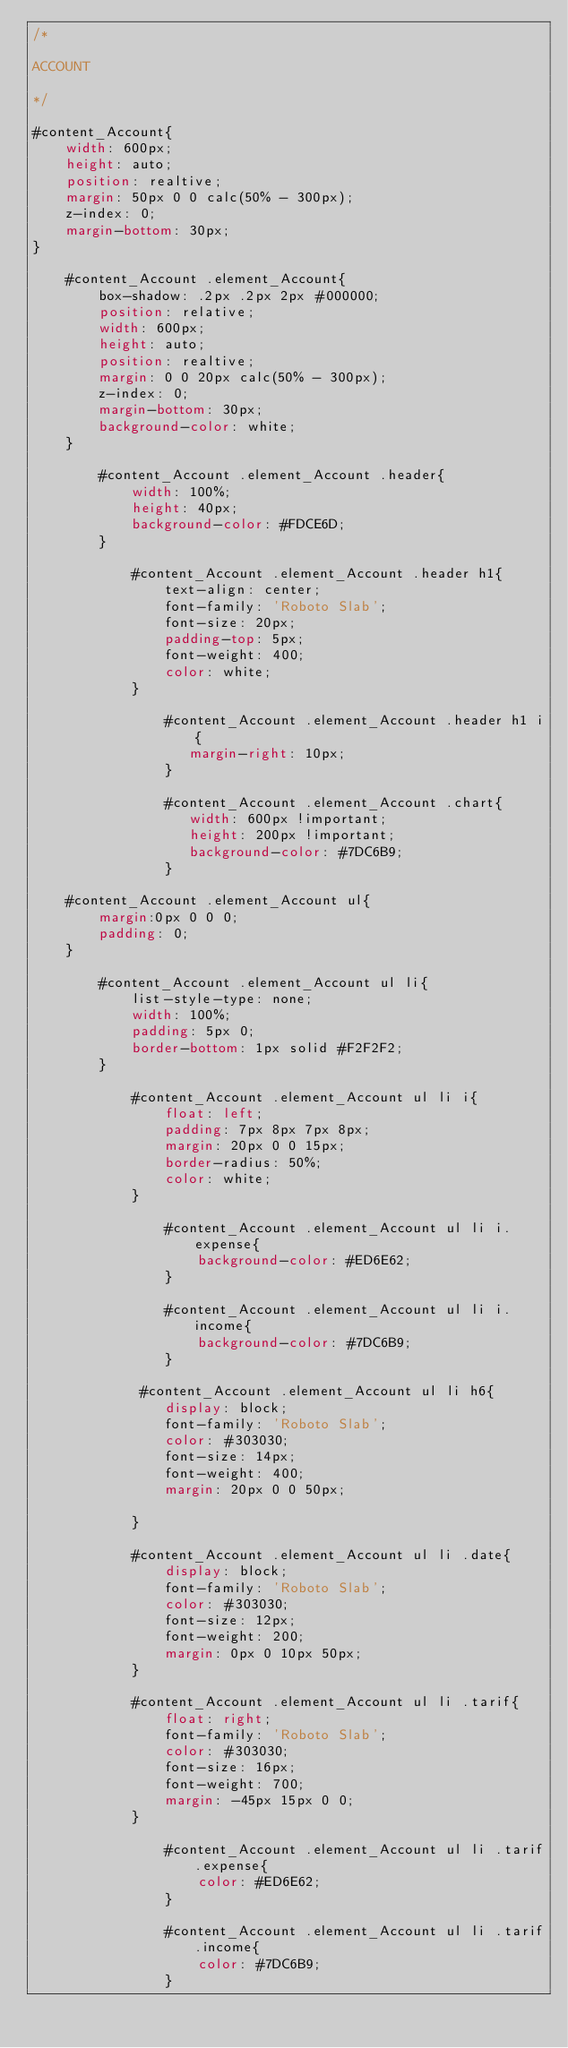<code> <loc_0><loc_0><loc_500><loc_500><_CSS_>/*

ACCOUNT

*/

#content_Account{
    width: 600px;
    height: auto;
    position: realtive;
    margin: 50px 0 0 calc(50% - 300px);
    z-index: 0;
    margin-bottom: 30px;
}

    #content_Account .element_Account{
        box-shadow: .2px .2px 2px #000000;
        position: relative;
        width: 600px;
        height: auto;
        position: realtive;
        margin: 0 0 20px calc(50% - 300px);
        z-index: 0;
        margin-bottom: 30px;
        background-color: white;
    }

        #content_Account .element_Account .header{
            width: 100%;
            height: 40px;
            background-color: #FDCE6D;
        }

            #content_Account .element_Account .header h1{
                text-align: center;
                font-family: 'Roboto Slab';
                font-size: 20px;
                padding-top: 5px;
                font-weight: 400;
                color: white;
            }

                #content_Account .element_Account .header h1 i{
                   margin-right: 10px;
                }

                #content_Account .element_Account .chart{
                   width: 600px !important;
                   height: 200px !important;
                   background-color: #7DC6B9;
                }

    #content_Account .element_Account ul{
        margin:0px 0 0 0;
        padding: 0;
    }

        #content_Account .element_Account ul li{
            list-style-type: none;
            width: 100%;
            padding: 5px 0;
            border-bottom: 1px solid #F2F2F2;
        }

            #content_Account .element_Account ul li i{
                float: left;
                padding: 7px 8px 7px 8px;
                margin: 20px 0 0 15px;
                border-radius: 50%;
                color: white;
            }

                #content_Account .element_Account ul li i.expense{
                    background-color: #ED6E62;
                }

                #content_Account .element_Account ul li i.income{
                    background-color: #7DC6B9;
                }

             #content_Account .element_Account ul li h6{
                display: block;
                font-family: 'Roboto Slab';
                color: #303030;
                font-size: 14px;
                font-weight: 400;
                margin: 20px 0 0 50px;
                    
            }

            #content_Account .element_Account ul li .date{
                display: block;
                font-family: 'Roboto Slab';
                color: #303030;
                font-size: 12px;
                font-weight: 200;
                margin: 0px 0 10px 50px;
            }

            #content_Account .element_Account ul li .tarif{
                float: right;
                font-family: 'Roboto Slab';
                color: #303030;
                font-size: 16px;
                font-weight: 700;
                margin: -45px 15px 0 0;
            }

                #content_Account .element_Account ul li .tarif.expense{
                    color: #ED6E62;
                }

                #content_Account .element_Account ul li .tarif.income{
                    color: #7DC6B9;
                }





</code> 